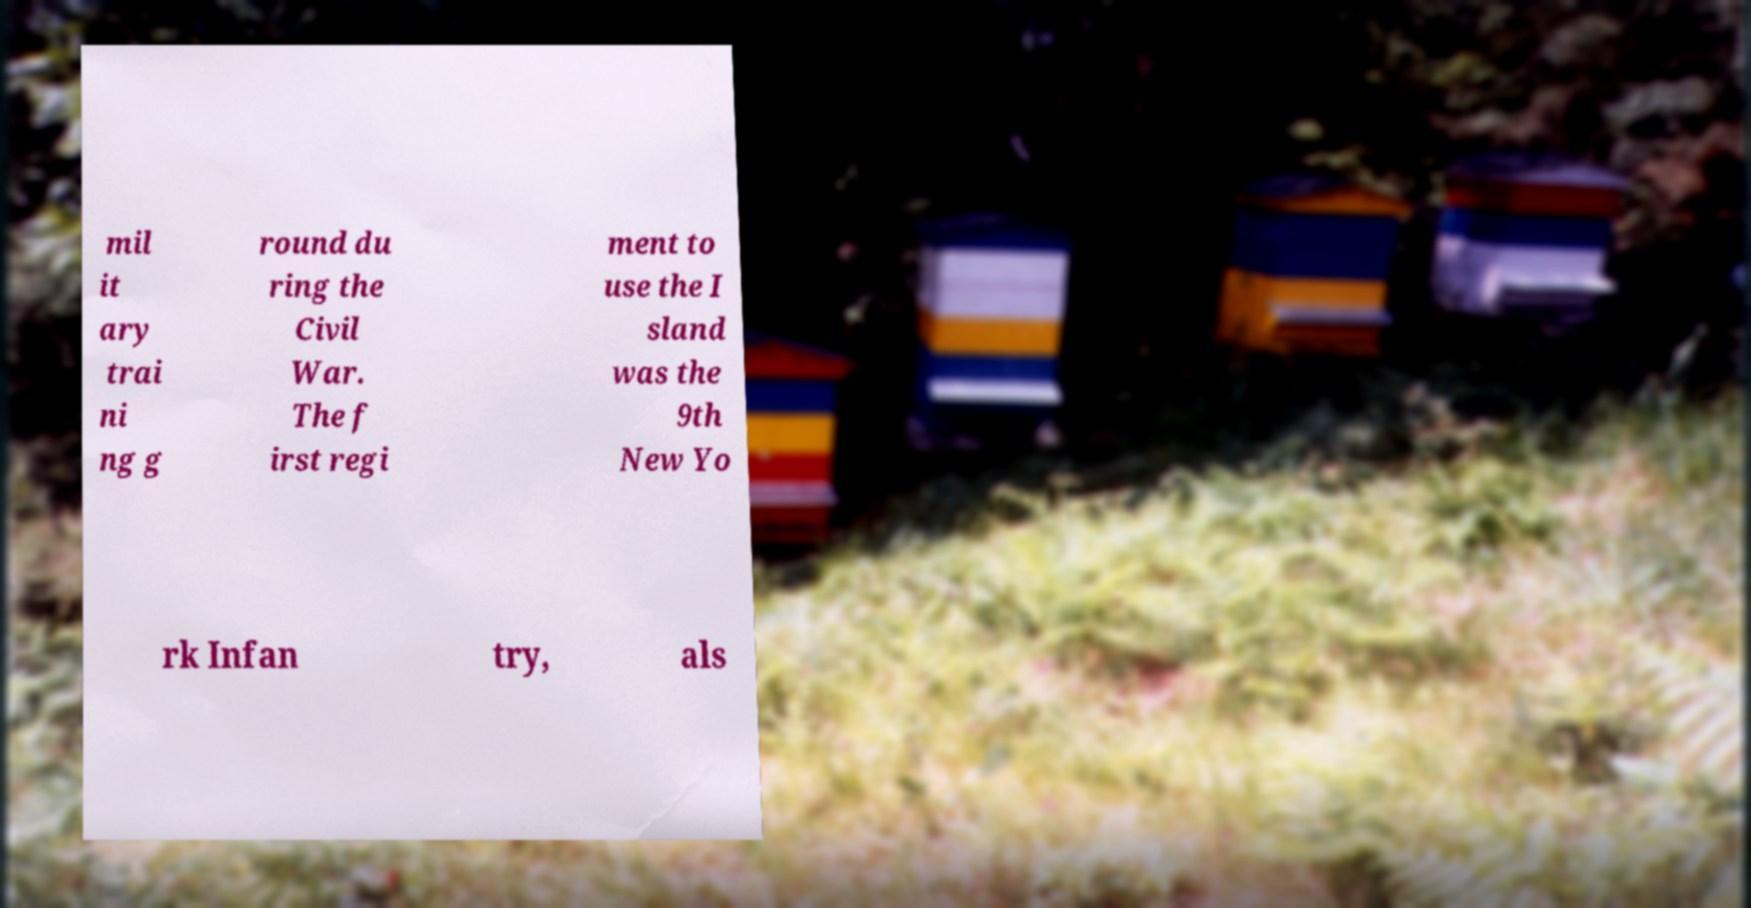For documentation purposes, I need the text within this image transcribed. Could you provide that? Certainly, the text in the image appears to be fragmented and somewhat hard to read due to the photo's blur, but here is the transcribed content as accurately as possible: 'Military training ground during the Civil War. The first regiment to use the Island was the 9th New York Infantry, also known as...' Unfortunately, the rest of the text is cut off and obscured by the image's background. 